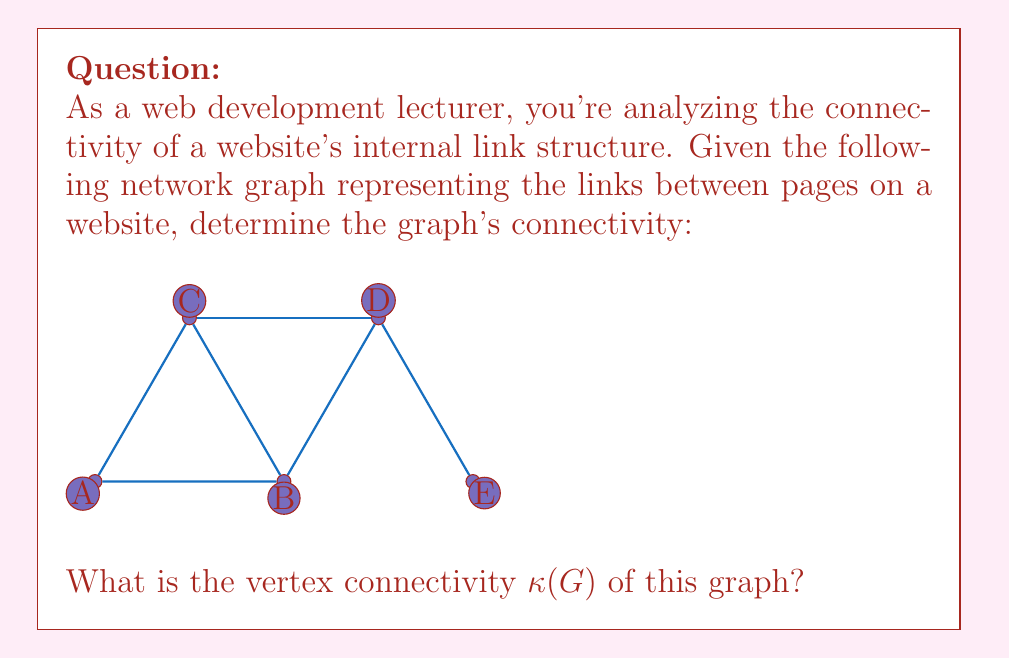Teach me how to tackle this problem. To determine the vertex connectivity $\kappa(G)$ of the graph, we need to find the minimum number of vertices whose removal would disconnect the graph or reduce it to a single vertex. Let's approach this step-by-step:

1) First, let's understand what vertex connectivity means:
   - $\kappa(G)$ is the minimum number of vertices that need to be removed to disconnect the graph.
   - For a connected graph that is not complete, $\kappa(G)$ is less than or equal to the minimum degree of the graph.

2) Analyze the graph:
   - The graph has 5 vertices (A, B, C, D, E).
   - It's connected but not complete.

3) Check for cut vertices (articulation points):
   - Removing vertex B would disconnect vertex E from the rest of the graph.
   - Removing vertex D would also disconnect vertex E from the rest of the graph.

4) Consider minimum degree:
   - Vertices A, C, and E have degree 2.
   - Vertices B and D have degree 4.
   - The minimum degree is 2.

5) Determine $\kappa(G)$:
   - Since removing a single vertex (B or D) can disconnect the graph, and this is the minimum number of vertices needed to do so, we conclude that $\kappa(G) = 1$.

6) Verify:
   - Removing any single vertex other than B or D does not disconnect the graph.
   - Removing either B or D disconnects vertex E from the rest of the graph.

Therefore, the vertex connectivity of this graph is 1.
Answer: $\kappa(G) = 1$ 